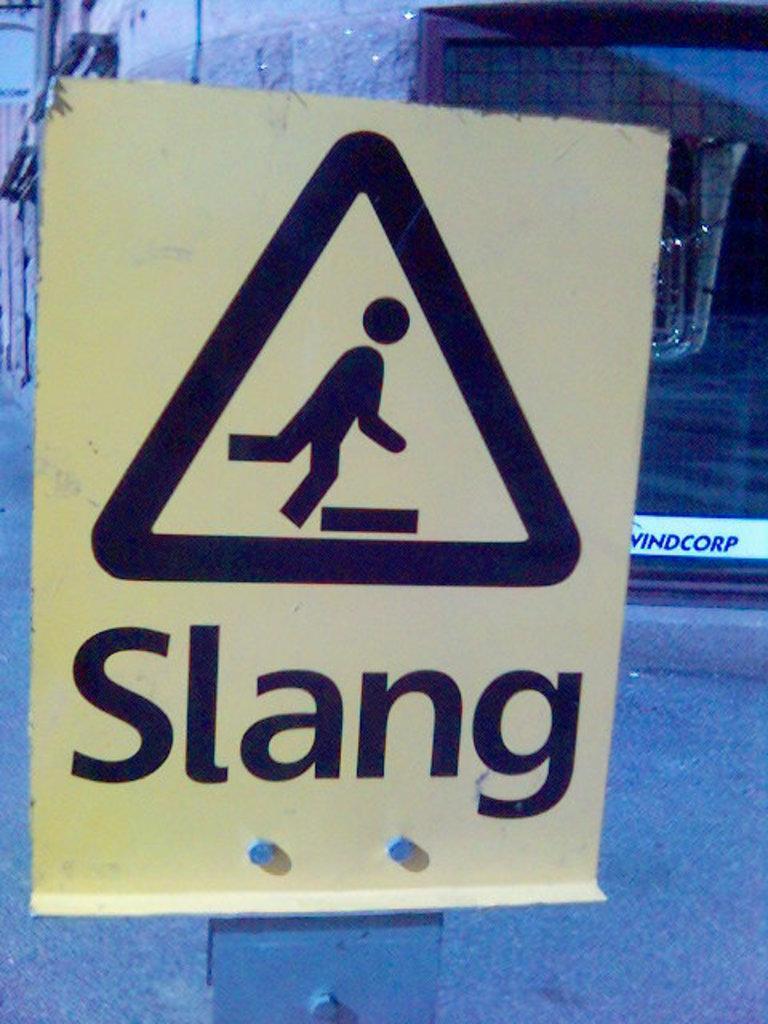Please provide a concise description of this image. In the foreground of the picture there is a sign board. In the background there are buildings. At the bottom it is road. 